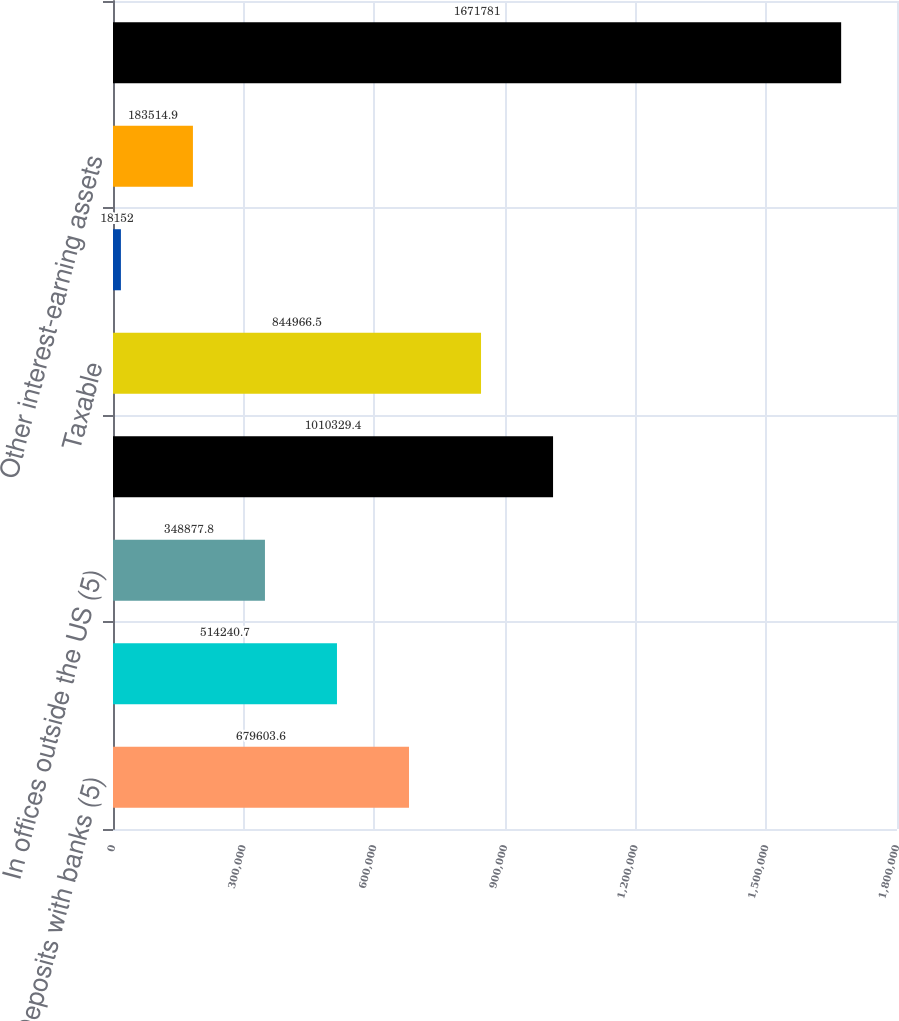Convert chart. <chart><loc_0><loc_0><loc_500><loc_500><bar_chart><fcel>Deposits with banks (5)<fcel>In US offices<fcel>In offices outside the US (5)<fcel>Total<fcel>Taxable<fcel>Exempt from US income tax<fcel>Other interest-earning assets<fcel>Total interest-earning assets<nl><fcel>679604<fcel>514241<fcel>348878<fcel>1.01033e+06<fcel>844966<fcel>18152<fcel>183515<fcel>1.67178e+06<nl></chart> 